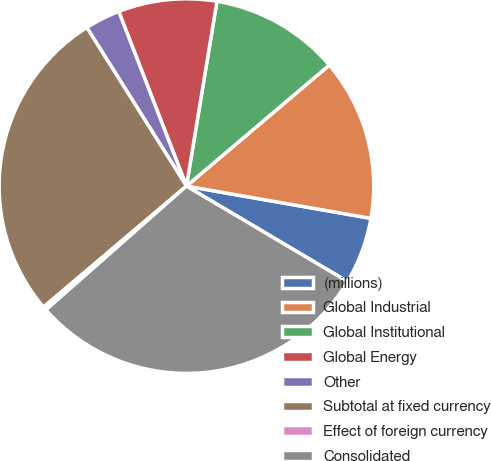Convert chart to OTSL. <chart><loc_0><loc_0><loc_500><loc_500><pie_chart><fcel>(millions)<fcel>Global Industrial<fcel>Global Institutional<fcel>Global Energy<fcel>Other<fcel>Subtotal at fixed currency<fcel>Effect of foreign currency<fcel>Consolidated<nl><fcel>5.76%<fcel>13.94%<fcel>11.21%<fcel>8.49%<fcel>3.04%<fcel>27.26%<fcel>0.31%<fcel>29.99%<nl></chart> 